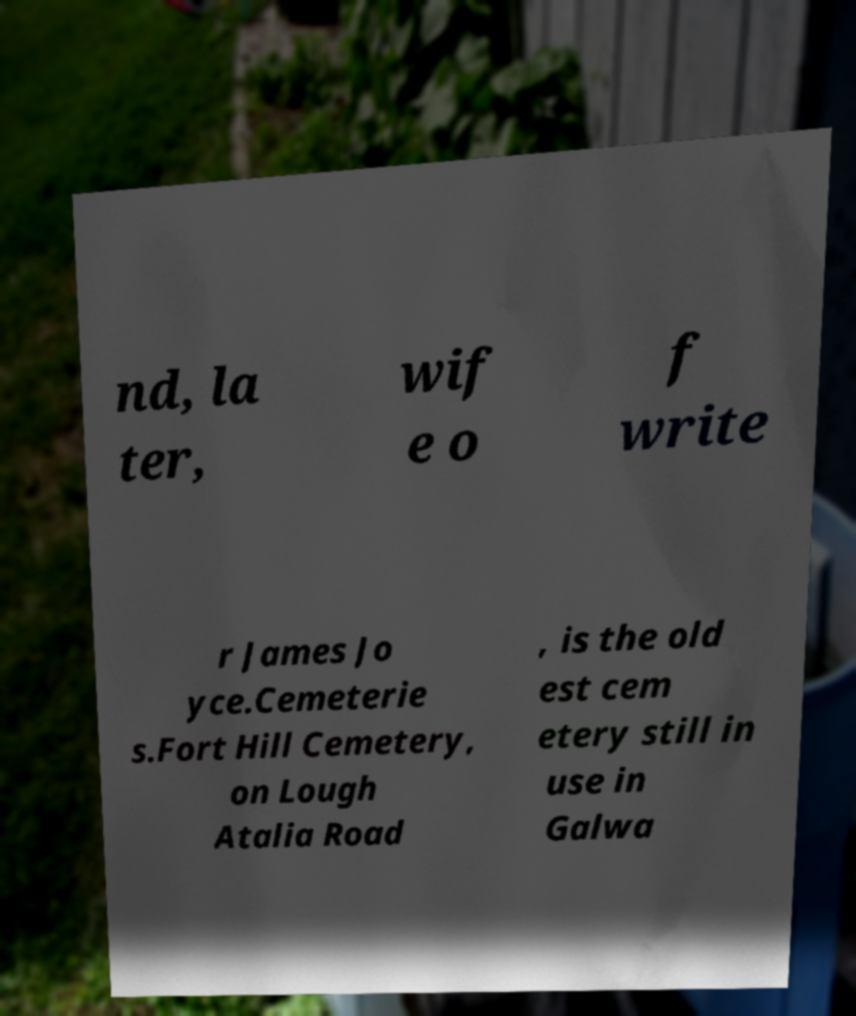Please identify and transcribe the text found in this image. nd, la ter, wif e o f write r James Jo yce.Cemeterie s.Fort Hill Cemetery, on Lough Atalia Road , is the old est cem etery still in use in Galwa 